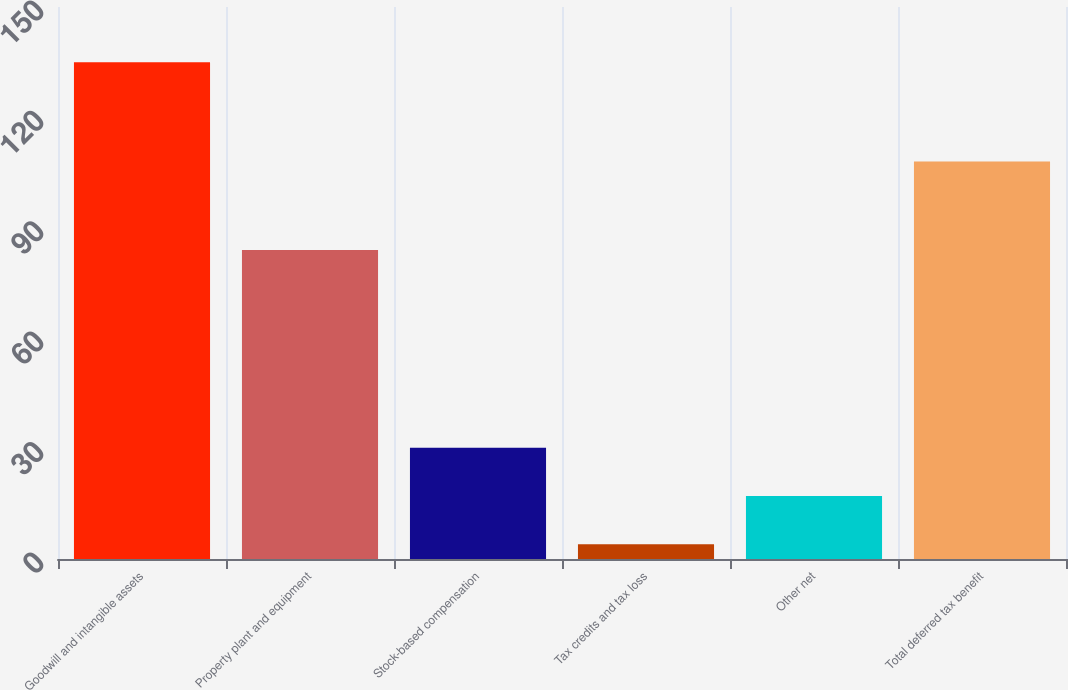<chart> <loc_0><loc_0><loc_500><loc_500><bar_chart><fcel>Goodwill and intangible assets<fcel>Property plant and equipment<fcel>Stock-based compensation<fcel>Tax credits and tax loss<fcel>Other net<fcel>Total deferred tax benefit<nl><fcel>135<fcel>84<fcel>30.2<fcel>4<fcel>17.1<fcel>108<nl></chart> 